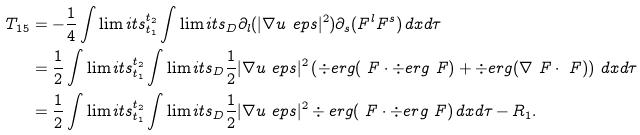Convert formula to latex. <formula><loc_0><loc_0><loc_500><loc_500>T _ { 1 5 } & = - \frac { 1 } { 4 } \int \lim i t s _ { t _ { 1 } } ^ { t _ { 2 } } \int \lim i t s _ { D } \partial _ { l } ( | \nabla u _ { \ } e p s | ^ { 2 } ) \partial _ { s } ( F ^ { l } F ^ { s } ) \, d x d \tau \\ & = \frac { 1 } { 2 } \int \lim i t s _ { t _ { 1 } } ^ { t _ { 2 } } \int \lim i t s _ { D } \frac { 1 } { 2 } | \nabla u _ { \ } e p s | ^ { 2 } \left ( \div e r g ( \ F \cdot \div e r g \ F ) + \div e r g ( \nabla \ F \cdot \ F ) \right ) \, d x d \tau \\ & = \frac { 1 } { 2 } \int \lim i t s _ { t _ { 1 } } ^ { t _ { 2 } } \int \lim i t s _ { D } \frac { 1 } { 2 } | \nabla u _ { \ } e p s | ^ { 2 } \div e r g ( \ F \cdot \div e r g \ F ) \, d x d \tau - R _ { 1 } .</formula> 